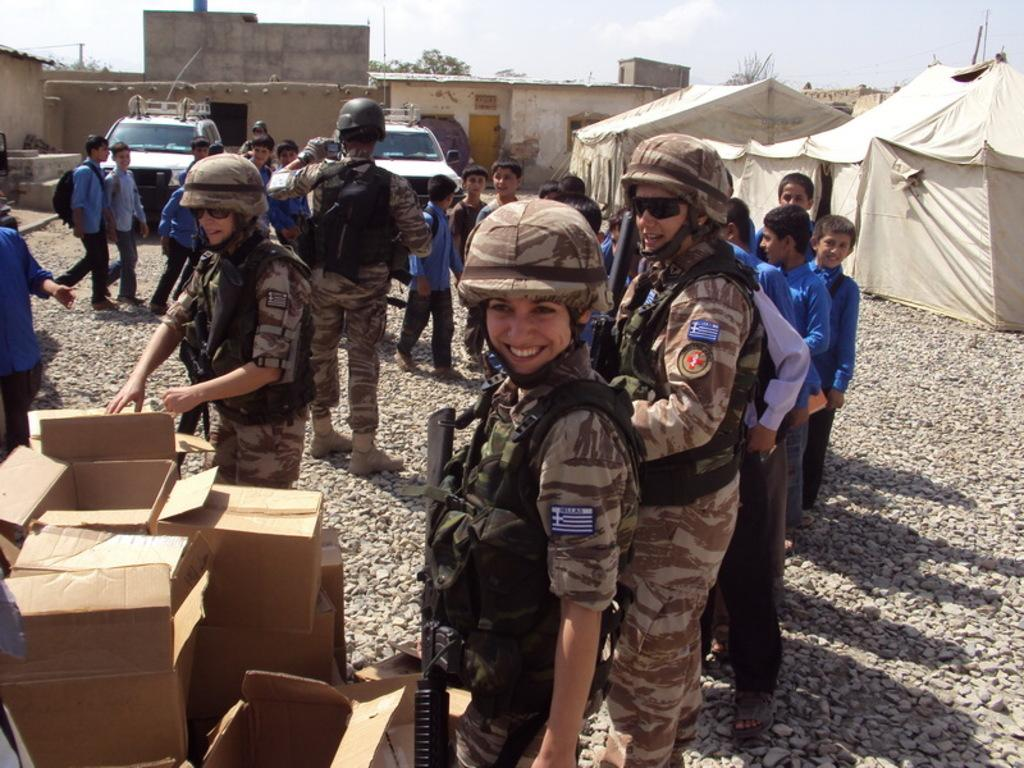What is happening in the image? There are many people standing on the ground in the image. Where are the boxes located in the image? The boxes are at the bottom left of the image. What can be seen in the background of the image? There are two cars and small houses in the background of the image. What type of cap is being worn by the people in the image? There is no mention of caps in the image, so it is not possible to determine what type of cap is being worn. 